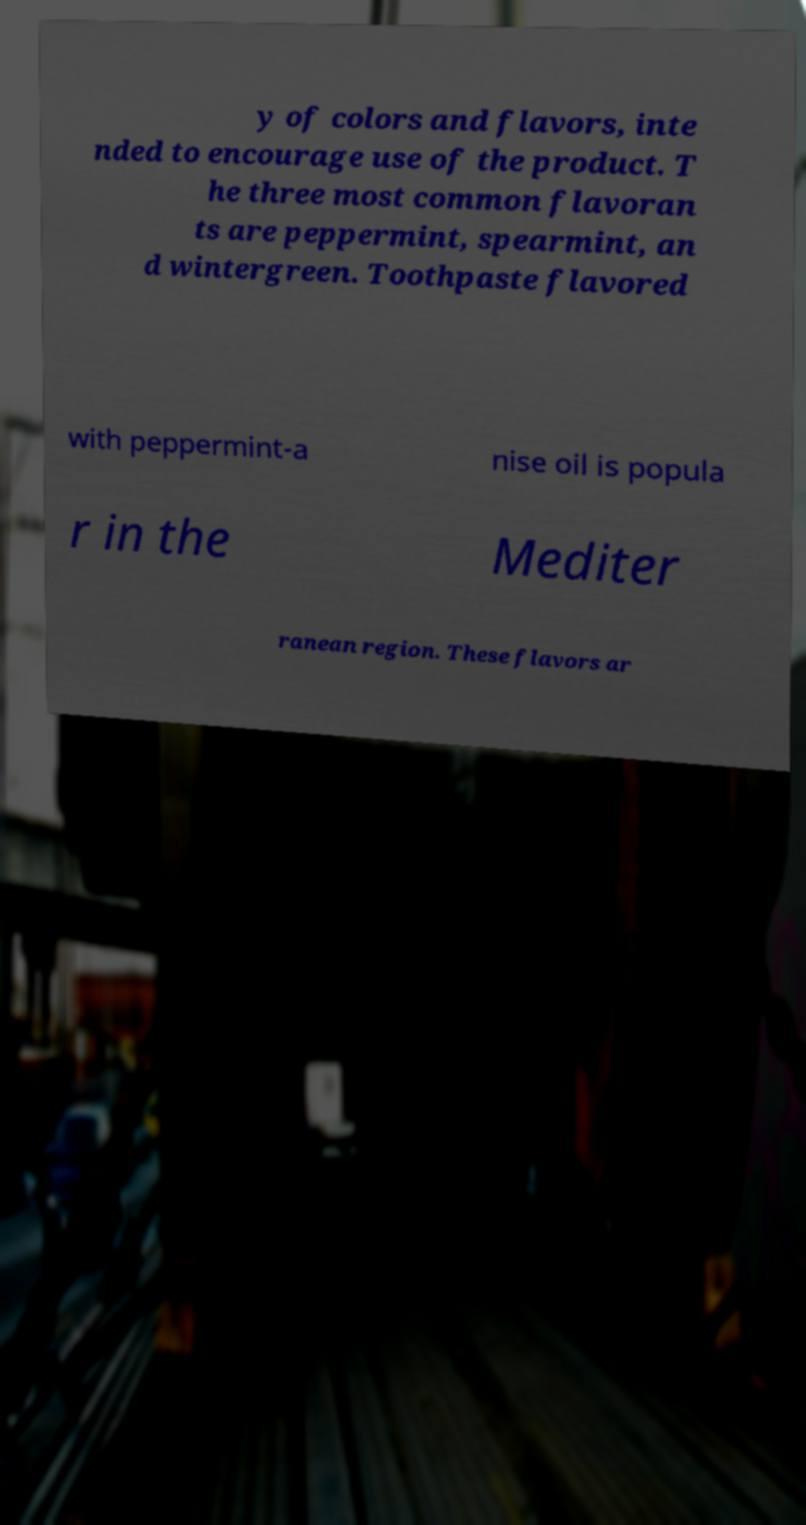There's text embedded in this image that I need extracted. Can you transcribe it verbatim? y of colors and flavors, inte nded to encourage use of the product. T he three most common flavoran ts are peppermint, spearmint, an d wintergreen. Toothpaste flavored with peppermint-a nise oil is popula r in the Mediter ranean region. These flavors ar 